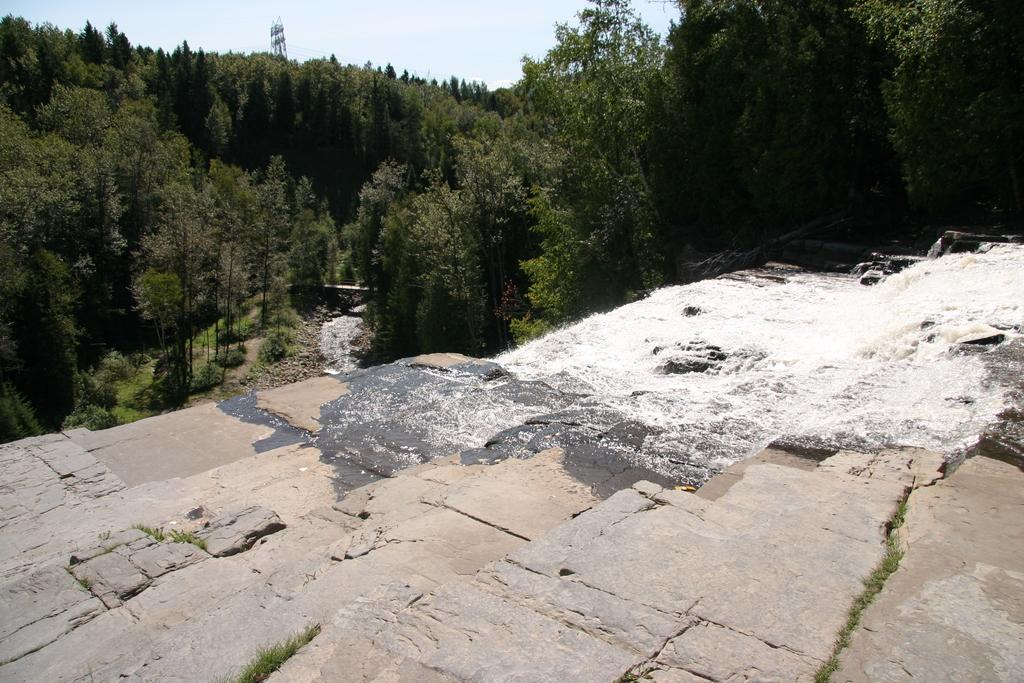What is the primary element visible in the image? There is water in the image. What architectural feature can be seen in the image? There are steps in the image. What type of vegetation is visible in the background of the image? There are trees in the background of the image. What part of the natural environment is visible in the image? The sky is visible in the background of the image. What type of digestion can be observed in the image? There is no digestion present in the image; it features water, steps, trees, and the sky. Can you see a train in the image? No, there is no train visible in the image. 